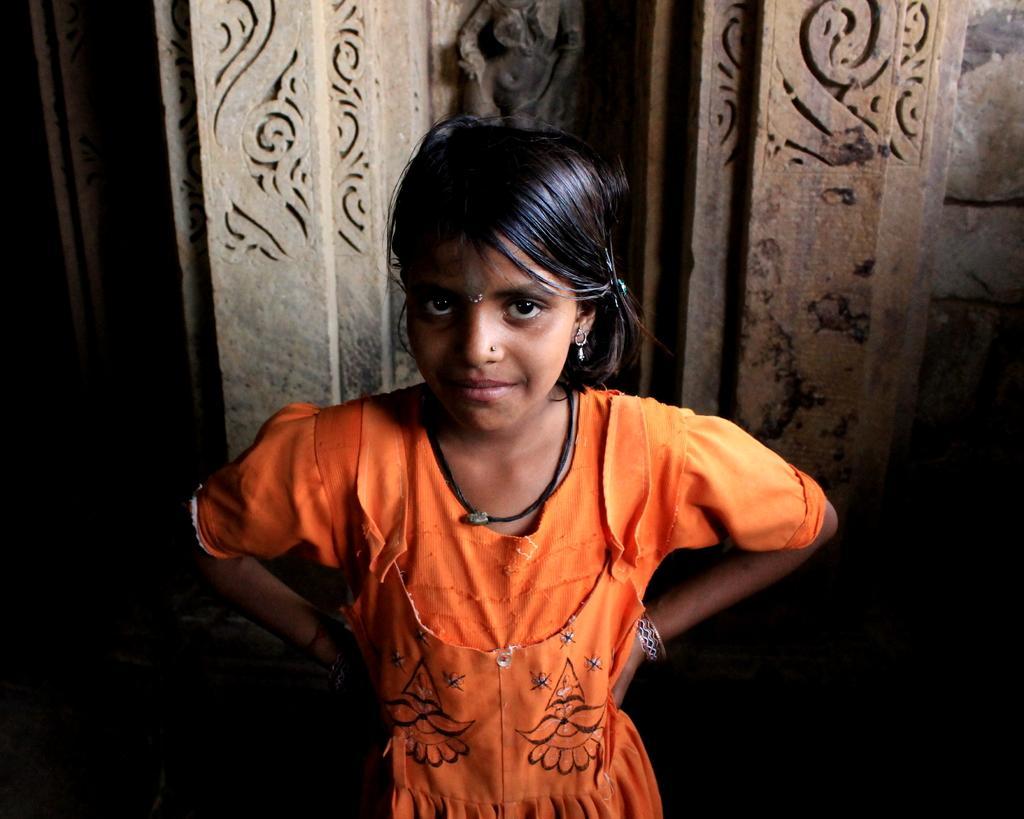Can you describe this image briefly? In this picture there is a girl standing and at the back side there is a wall. 